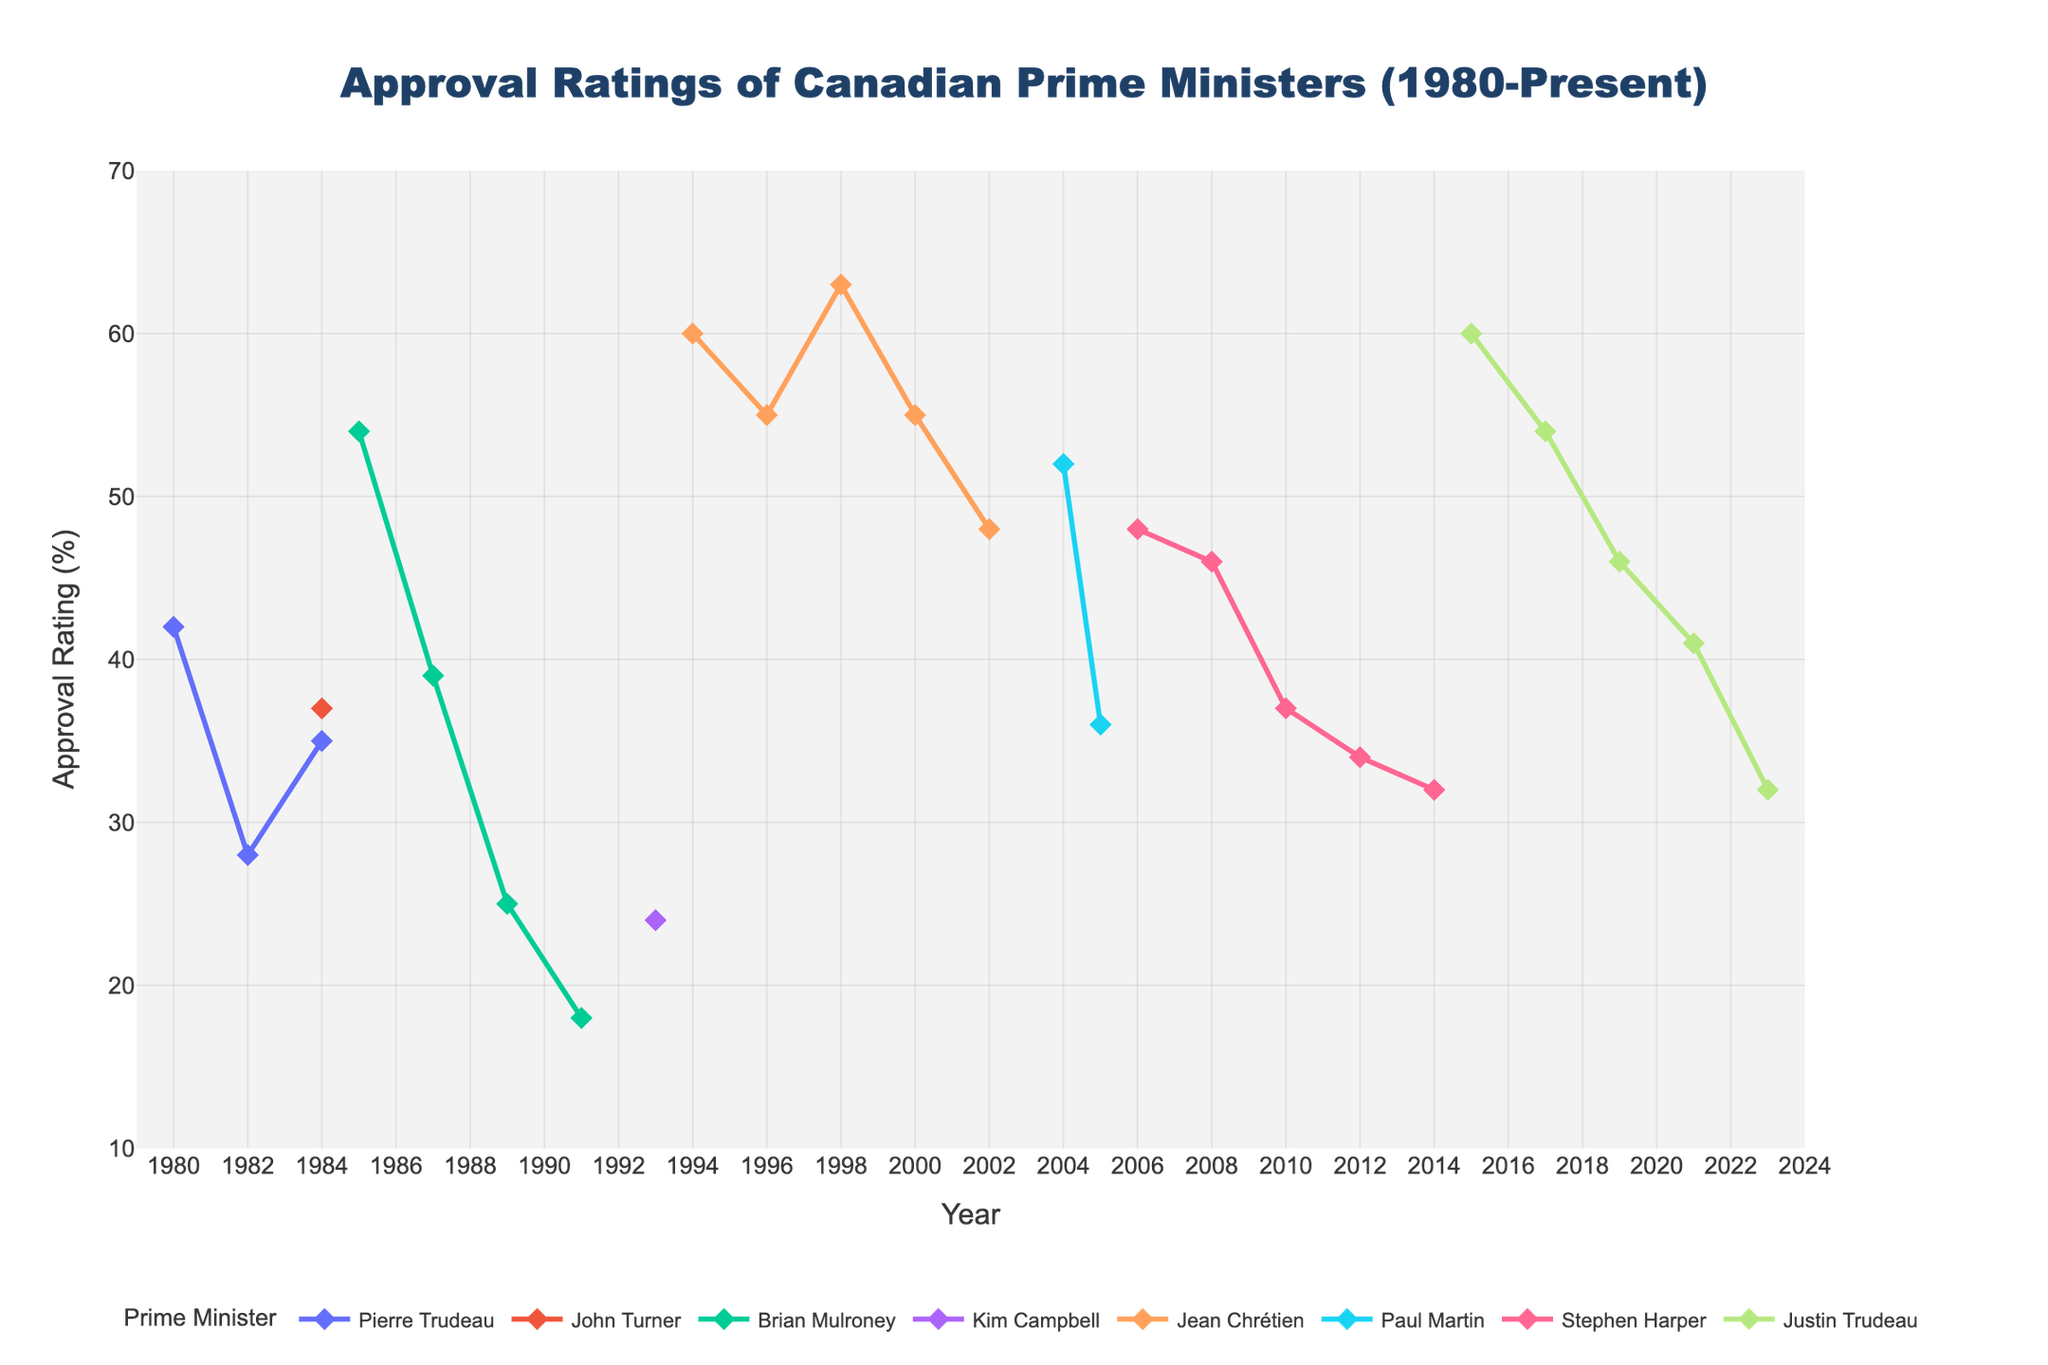What's the highest approval rating achieved by any Prime Minister? Look at the peak points of all the lines on the chart. The highest point is reached by Jean Chrétien in 1998 and Justin Trudeau in 2015, both at 63%.
Answer: 63% Which Prime Minister had the lowest approval rating and in what year? Look for the lowest point in the chart. The lowest approval rating is Brian Mulroney in 1991 at 18%.
Answer: Brian Mulroney in 1991 Did any Prime Minister experience a consistent drop in approval ratings over their tenure? Observe the trends in the lines. Brian Mulroney's approval rating dropped continuously from 1985 to 1991.
Answer: Brian Mulroney Compare the approval ratings of Justin Trudeau in 2017 and 2023. Justin Trudeau's approval rating in 2017 is 54%, and in 2023 it is 32%.
Answer: 54% in 2017, 32% in 2023 Calculate the average approval rating for Jean Chrétien during his tenure. Jean Chrétien's approval ratings are 60% (1994), 55% (1996), 63% (1998), 55% (2000), and 48% (2002). Add them (60 + 55 + 63 + 55 + 48) = 281, and divide by 5 to get 56.2%.
Answer: 56.2% Who had the highest approval rating longer into their tenure: Paul Martin or Stephen Harper? Paul Martin's approval ratings are 52% (2004) and 36% (2005), Stephen Harper's approval ratings are 48% (2006) to 32% (2014). Stephen Harper remained higher longer as 48% in 2006 to 32% in 2014.
Answer: Stephen Harper Identify the Prime Ministers with over 50% approval ratings in their first recorded year. Look at the first points of each line corresponding to each Prime Minister: Brian Mulroney (54% in 1985), Jean Chrétien (60% in 1994), Paul Martin (52% in 2004), Justin Trudeau (60% in 2015).
Answer: Brian Mulroney, Jean Chrétien, Paul Martin, Justin Trudeau What is the range of approval ratings for Stephen Harper across his tenure? Stephen Harper's approval ratings are 48% (2006), 46% (2008), 37% (2010), 34% (2012), and 32% (2014). The range is the difference between the highest (48%) and lowest (32%) ratings, which is 48% - 32% = 16%.
Answer: 16% How did the approval rating of Pierre Trudeau change from his first recorded year to his last? Pierre Trudeau's approval ratings are 42% (1980) to 35% (1984). The change is 42% - 35% = -7%.
Answer: Decreased by 7% Was there any Prime Minister who experienced an increase in their approval rating after an initial drop? Yes, Jean Chrétien's approval rating dropped from 60% in 1994 to 55% in 1996, but then increased to 63% in 1998.
Answer: Jean Chrétien 